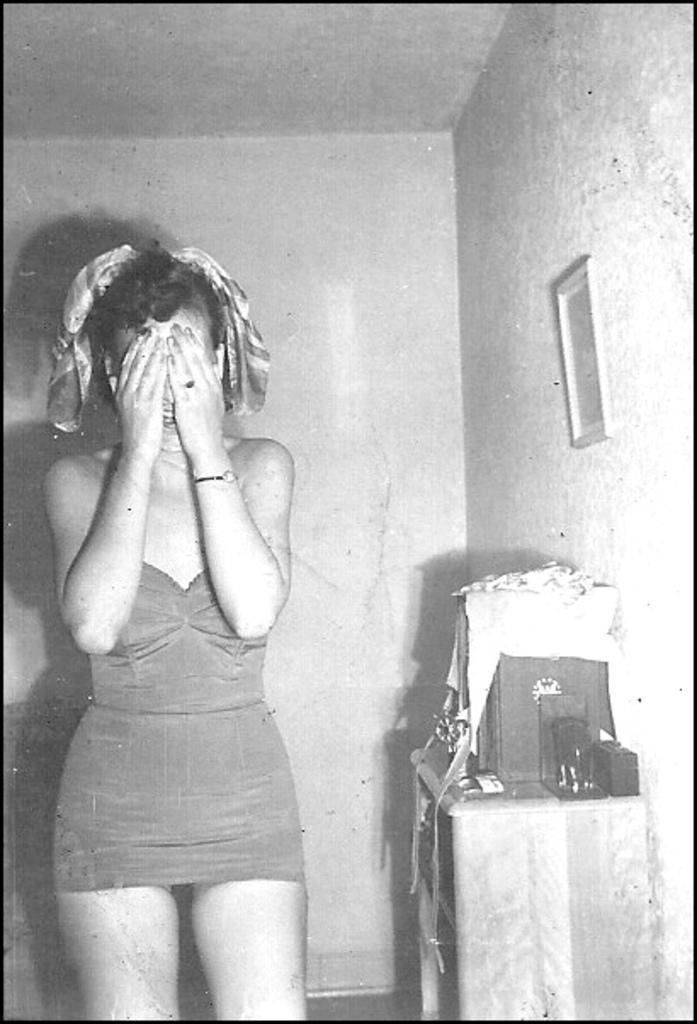Can you describe this image briefly? This is a black and white image. On the left side, I can see a woman standing and smiling. On the right side, I can see a table on which few objects are placed. In the background, I can see the wall to which a frame is attached. 